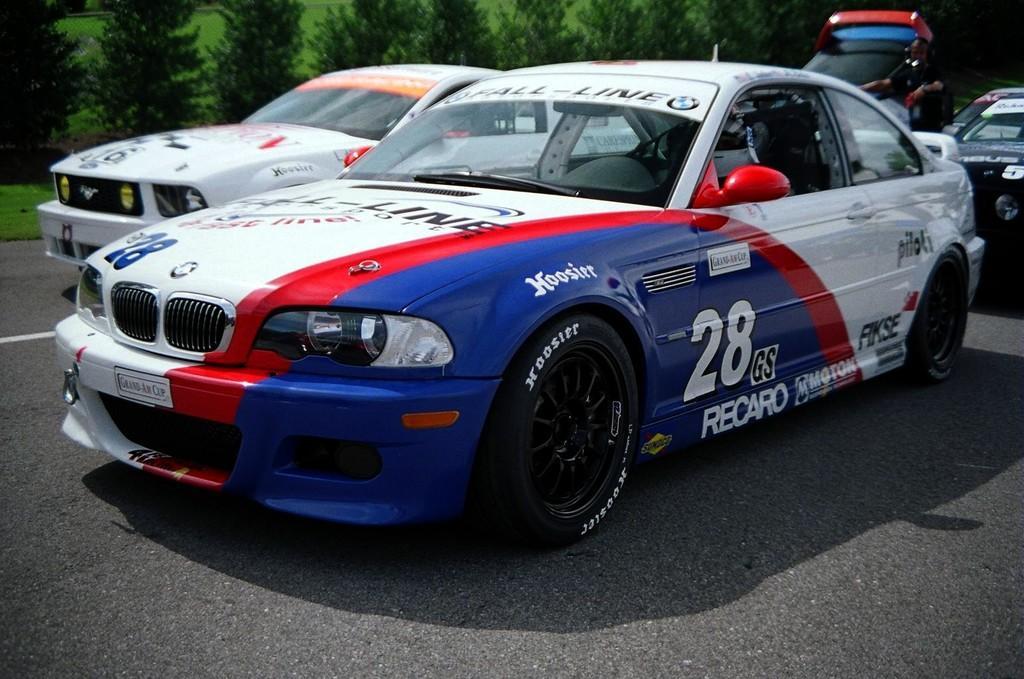How would you summarize this image in a sentence or two? In this picture we can observe some cars on the road. We can observe blue, red and white color car here. In the background there are trees. 